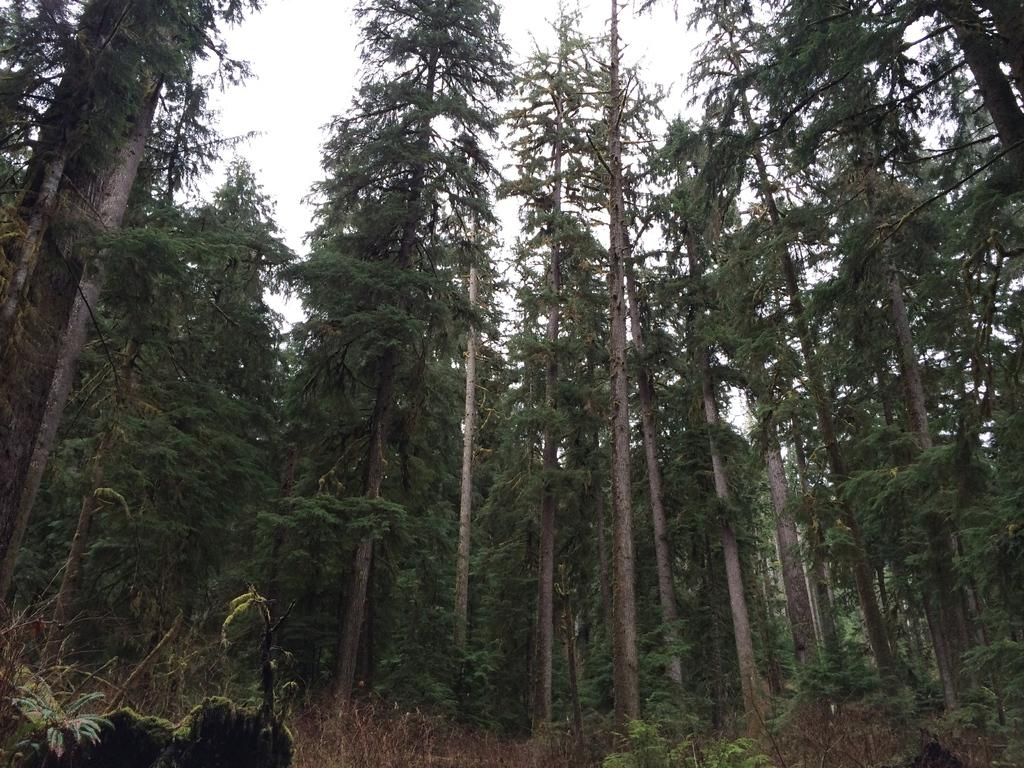What type of vegetation can be seen in the image? There are trees and plants on the ground in the image. How would you describe the sky in the image? The sky is cloudy in the image. What rule is being enforced in the jail depicted in the image? There is no jail present in the image; it features trees, plants, and a cloudy sky. 